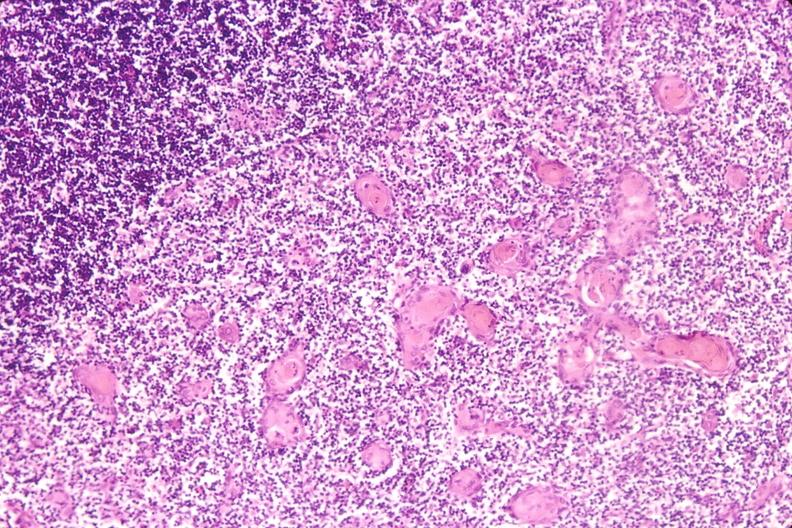does newborn cord around neck show thymus?
Answer the question using a single word or phrase. No 